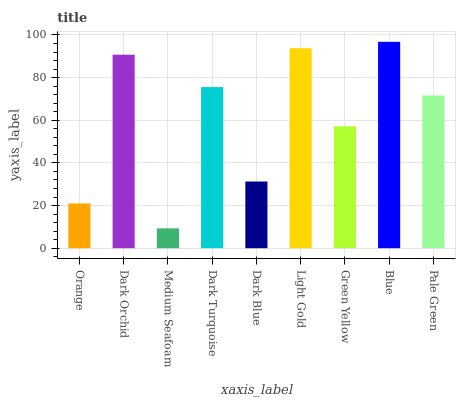Is Medium Seafoam the minimum?
Answer yes or no. Yes. Is Blue the maximum?
Answer yes or no. Yes. Is Dark Orchid the minimum?
Answer yes or no. No. Is Dark Orchid the maximum?
Answer yes or no. No. Is Dark Orchid greater than Orange?
Answer yes or no. Yes. Is Orange less than Dark Orchid?
Answer yes or no. Yes. Is Orange greater than Dark Orchid?
Answer yes or no. No. Is Dark Orchid less than Orange?
Answer yes or no. No. Is Pale Green the high median?
Answer yes or no. Yes. Is Pale Green the low median?
Answer yes or no. Yes. Is Dark Orchid the high median?
Answer yes or no. No. Is Blue the low median?
Answer yes or no. No. 